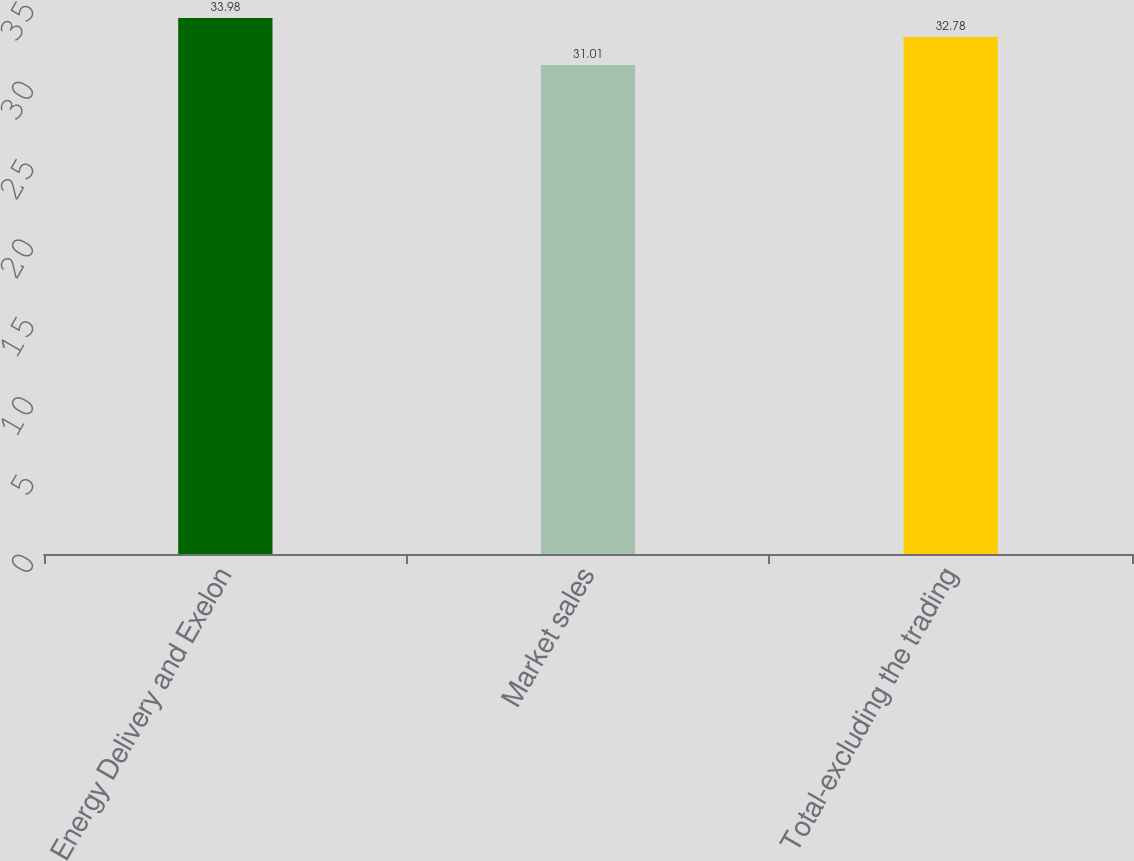<chart> <loc_0><loc_0><loc_500><loc_500><bar_chart><fcel>Energy Delivery and Exelon<fcel>Market sales<fcel>Total-excluding the trading<nl><fcel>33.98<fcel>31.01<fcel>32.78<nl></chart> 